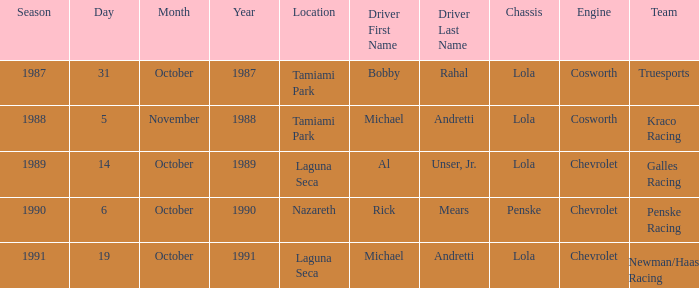At which location did Rick Mears drive? Nazareth. 